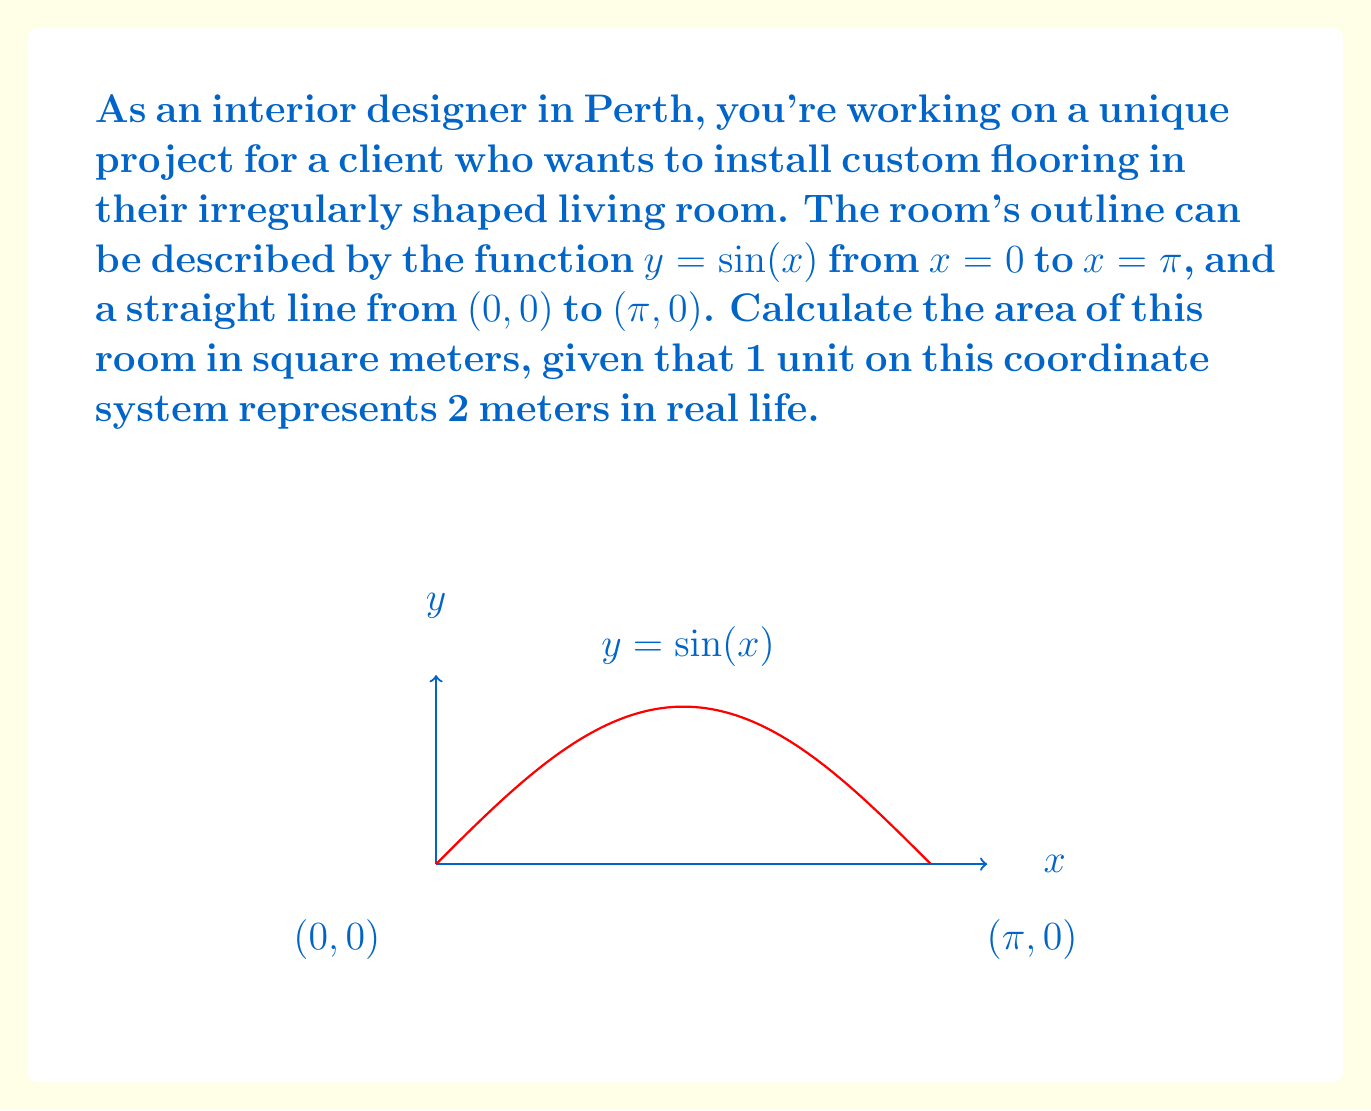Could you help me with this problem? Let's approach this step-by-step:

1) The area we need to calculate is bounded by the curve $y = \sin(x)$ from $x = 0$ to $x = \pi$, and the x-axis.

2) To find this area, we need to integrate the function $\sin(x)$ from 0 to $\pi$:

   $$A = \int_0^\pi \sin(x) dx$$

3) We can solve this integral:
   
   $$A = [-\cos(x)]_0^\pi = -\cos(\pi) - (-\cos(0)) = -(-1) - (-1) = 2$$

4) This gives us the area in square units of our coordinate system. However, we need to convert this to square meters.

5) We're told that 1 unit in our coordinate system represents 2 meters in real life. This means we need to multiply our area by $2^2 = 4$ to get the real area in square meters:

   $$A_{real} = 2 * 4 = 8$$

Therefore, the area of the room is 8 square meters.
Answer: 8 square meters 